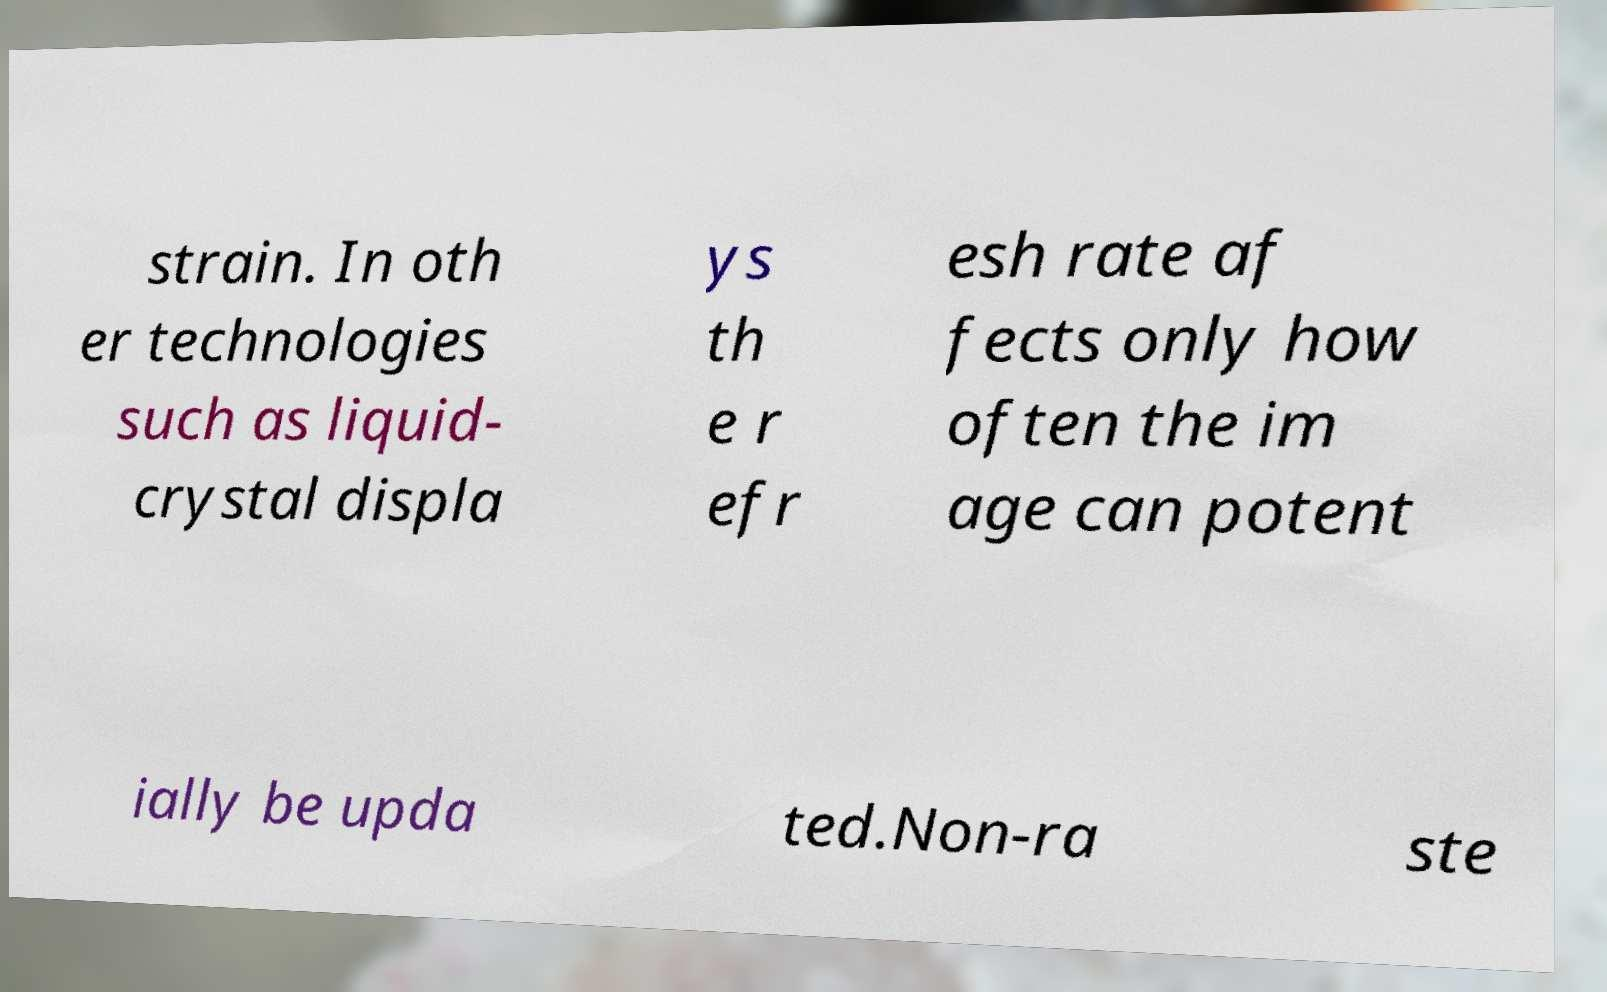What messages or text are displayed in this image? I need them in a readable, typed format. strain. In oth er technologies such as liquid- crystal displa ys th e r efr esh rate af fects only how often the im age can potent ially be upda ted.Non-ra ste 